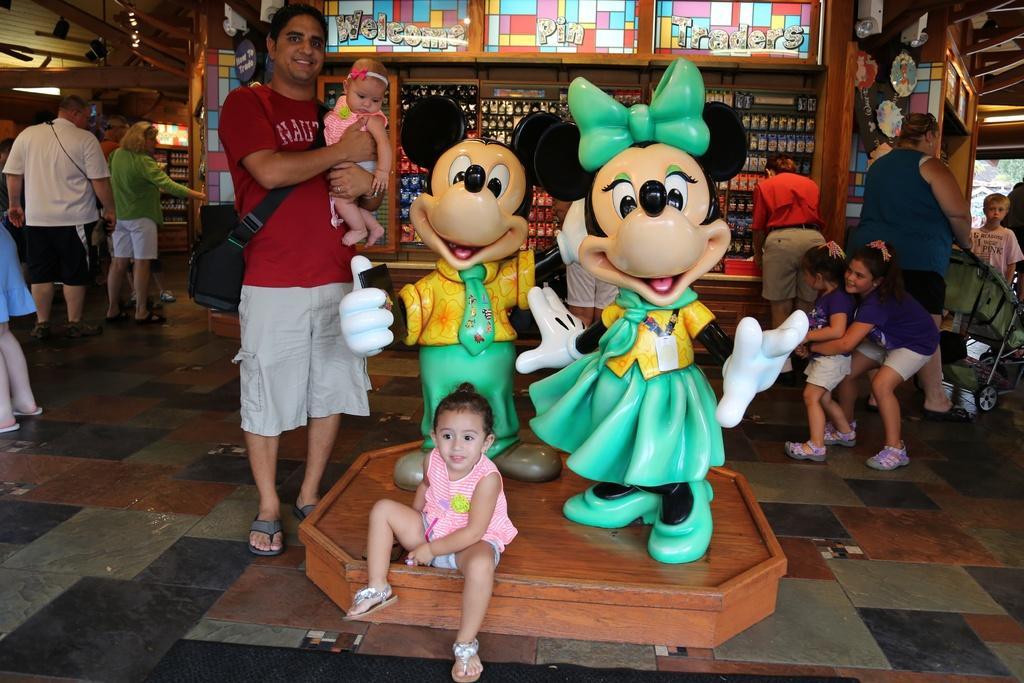How would you summarize this image in a sentence or two? This image is taken indoors. At the bottom of the image there is a floor. In the background there are a few walls and there are a few toy games. There are three boards with text on them. At the top of the image there is a roof and there are two CC-cams. In the middle of the image there are two statues of toys. A man is standing on the floor and he is holding a baby in his hands and a girl is sitting on the dais. On the left side of the image a few people are standing on the floor. On the right side of the image a few are standing and a woman is walking and she is holding a baby carrier. 